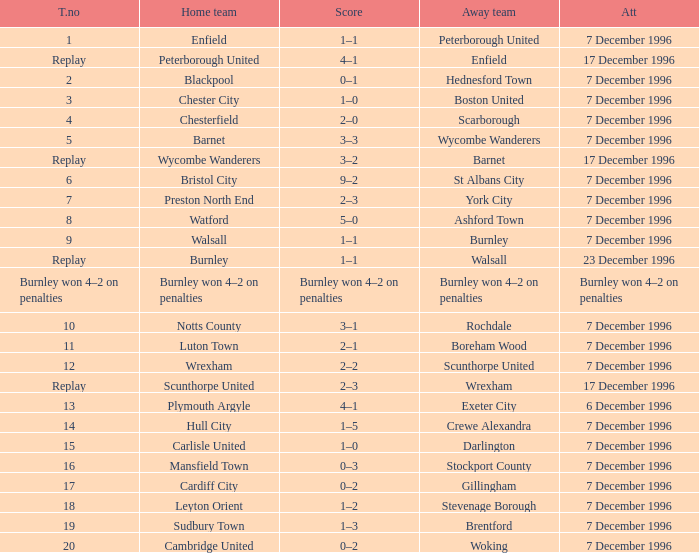What was the score of tie number 15? 1–0. 